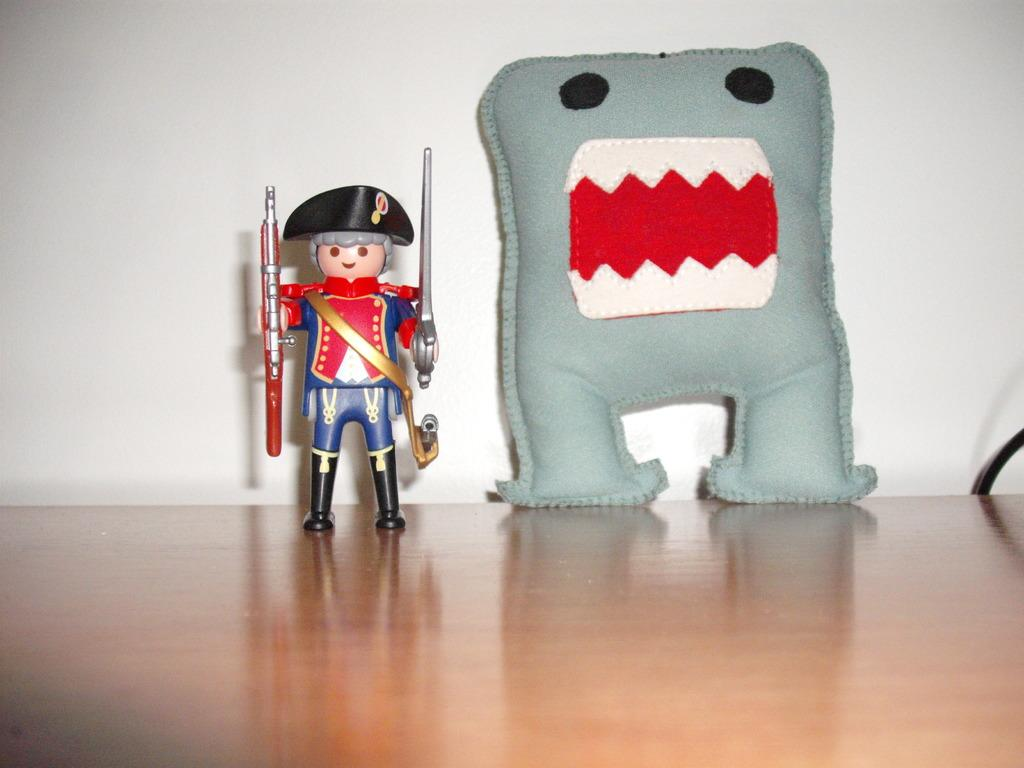What is on the platform in the image? There is a toy and a pillow on the platform. Can you describe the background of the image? There is a wall in the background of the image. What type of waste is visible on the platform in the image? There is no waste visible on the platform in the image. 